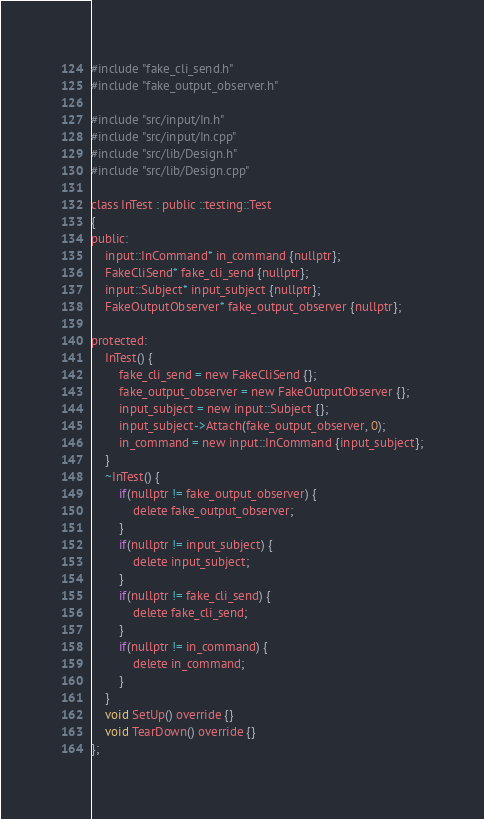Convert code to text. <code><loc_0><loc_0><loc_500><loc_500><_C_>
#include "fake_cli_send.h"
#include "fake_output_observer.h"

#include "src/input/In.h"
#include "src/input/In.cpp"
#include "src/lib/Design.h"
#include "src/lib/Design.cpp"

class InTest : public ::testing::Test
{
public:
    input::InCommand* in_command {nullptr};
    FakeCliSend* fake_cli_send {nullptr};
    input::Subject* input_subject {nullptr};
    FakeOutputObserver* fake_output_observer {nullptr};

protected:
    InTest() {
        fake_cli_send = new FakeCliSend {};
        fake_output_observer = new FakeOutputObserver {};
        input_subject = new input::Subject {};
        input_subject->Attach(fake_output_observer, 0);
        in_command = new input::InCommand {input_subject};
    }
    ~InTest() {
        if(nullptr != fake_output_observer) {
            delete fake_output_observer;
        }
        if(nullptr != input_subject) {
            delete input_subject;
        }
        if(nullptr != fake_cli_send) {
            delete fake_cli_send;
        }
        if(nullptr != in_command) {
            delete in_command;
        }
    }
    void SetUp() override {}
    void TearDown() override {}
};
</code> 